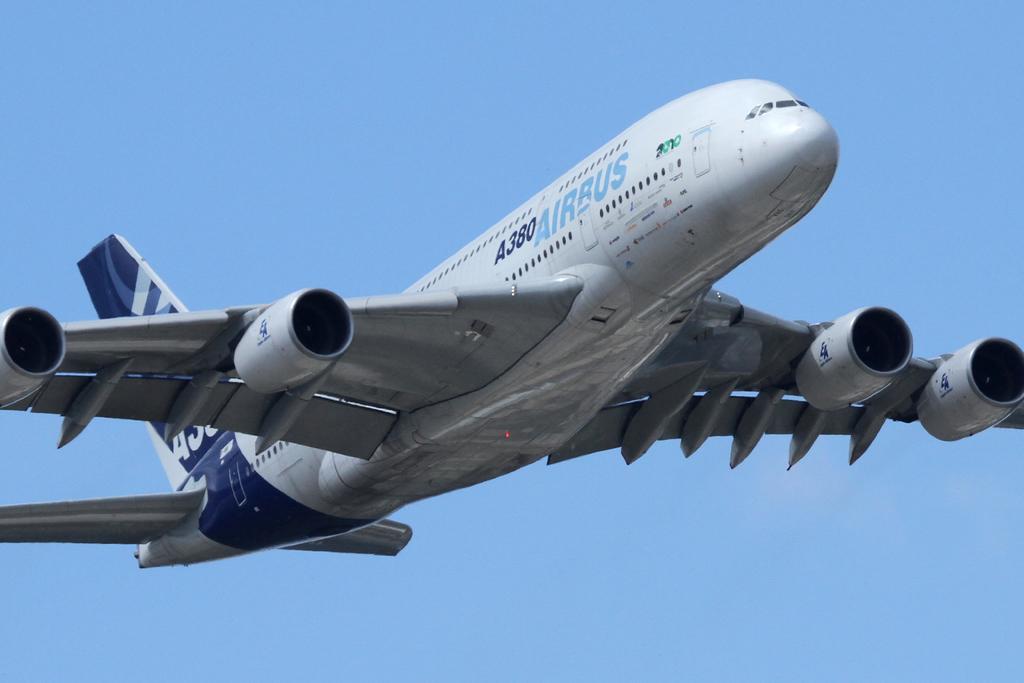What is this?
Offer a very short reply. Answering does not require reading text in the image. What is the identification number?
Offer a very short reply. A380. 